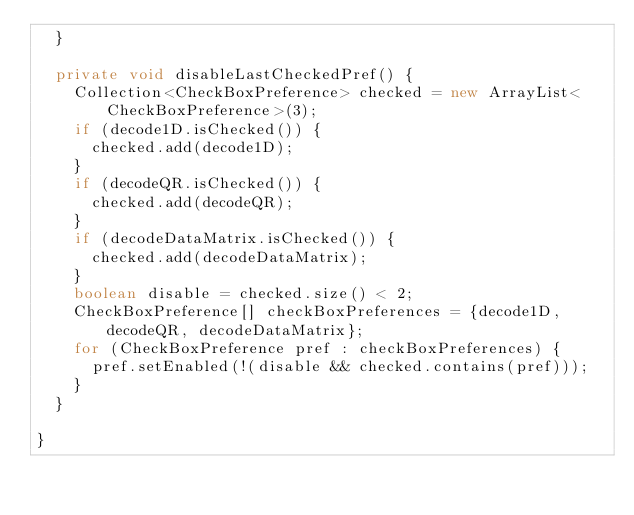Convert code to text. <code><loc_0><loc_0><loc_500><loc_500><_Java_>  }

  private void disableLastCheckedPref() {
    Collection<CheckBoxPreference> checked = new ArrayList<CheckBoxPreference>(3);
    if (decode1D.isChecked()) {
      checked.add(decode1D);
    }
    if (decodeQR.isChecked()) {
      checked.add(decodeQR);
    }
    if (decodeDataMatrix.isChecked()) {
      checked.add(decodeDataMatrix);
    }
    boolean disable = checked.size() < 2;
    CheckBoxPreference[] checkBoxPreferences = {decode1D, decodeQR, decodeDataMatrix};
    for (CheckBoxPreference pref : checkBoxPreferences) {
      pref.setEnabled(!(disable && checked.contains(pref)));
    }
  }

}
</code> 